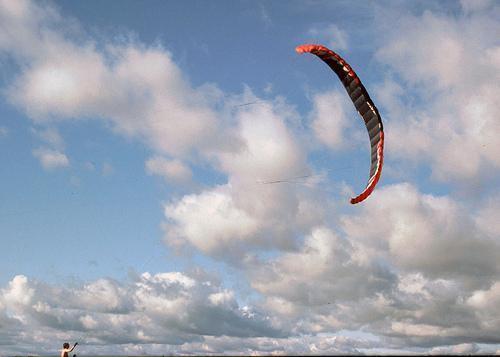How many kites are in the image?
Give a very brief answer. 1. 